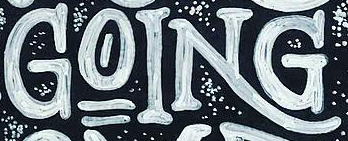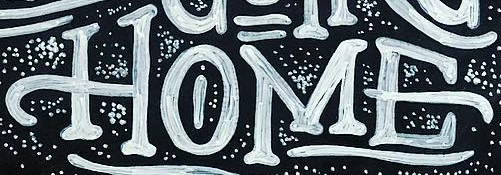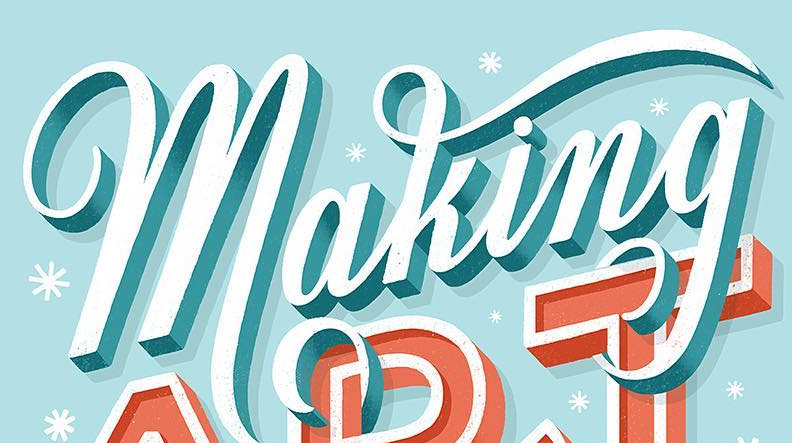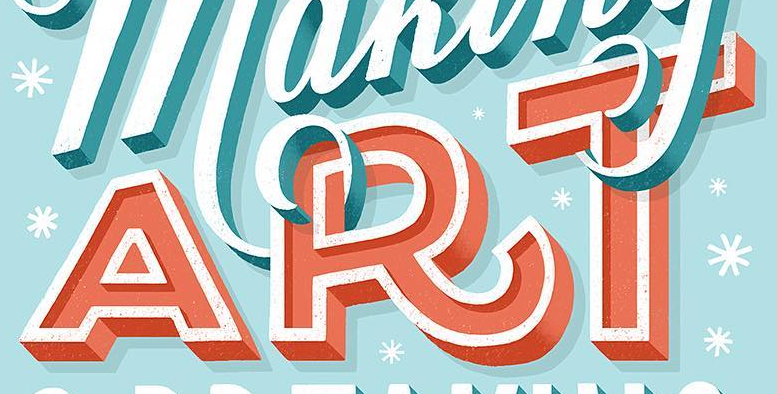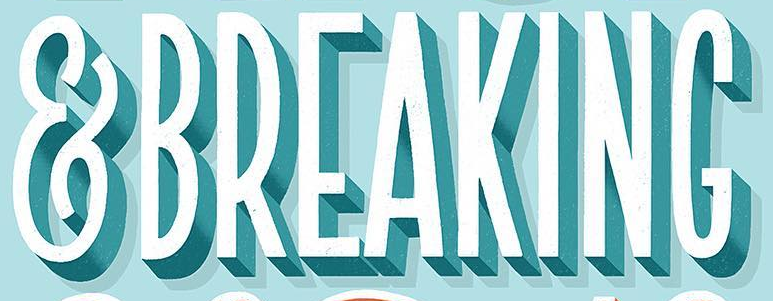What text is displayed in these images sequentially, separated by a semicolon? GOING; HOME; making; ART; &BREAKING 